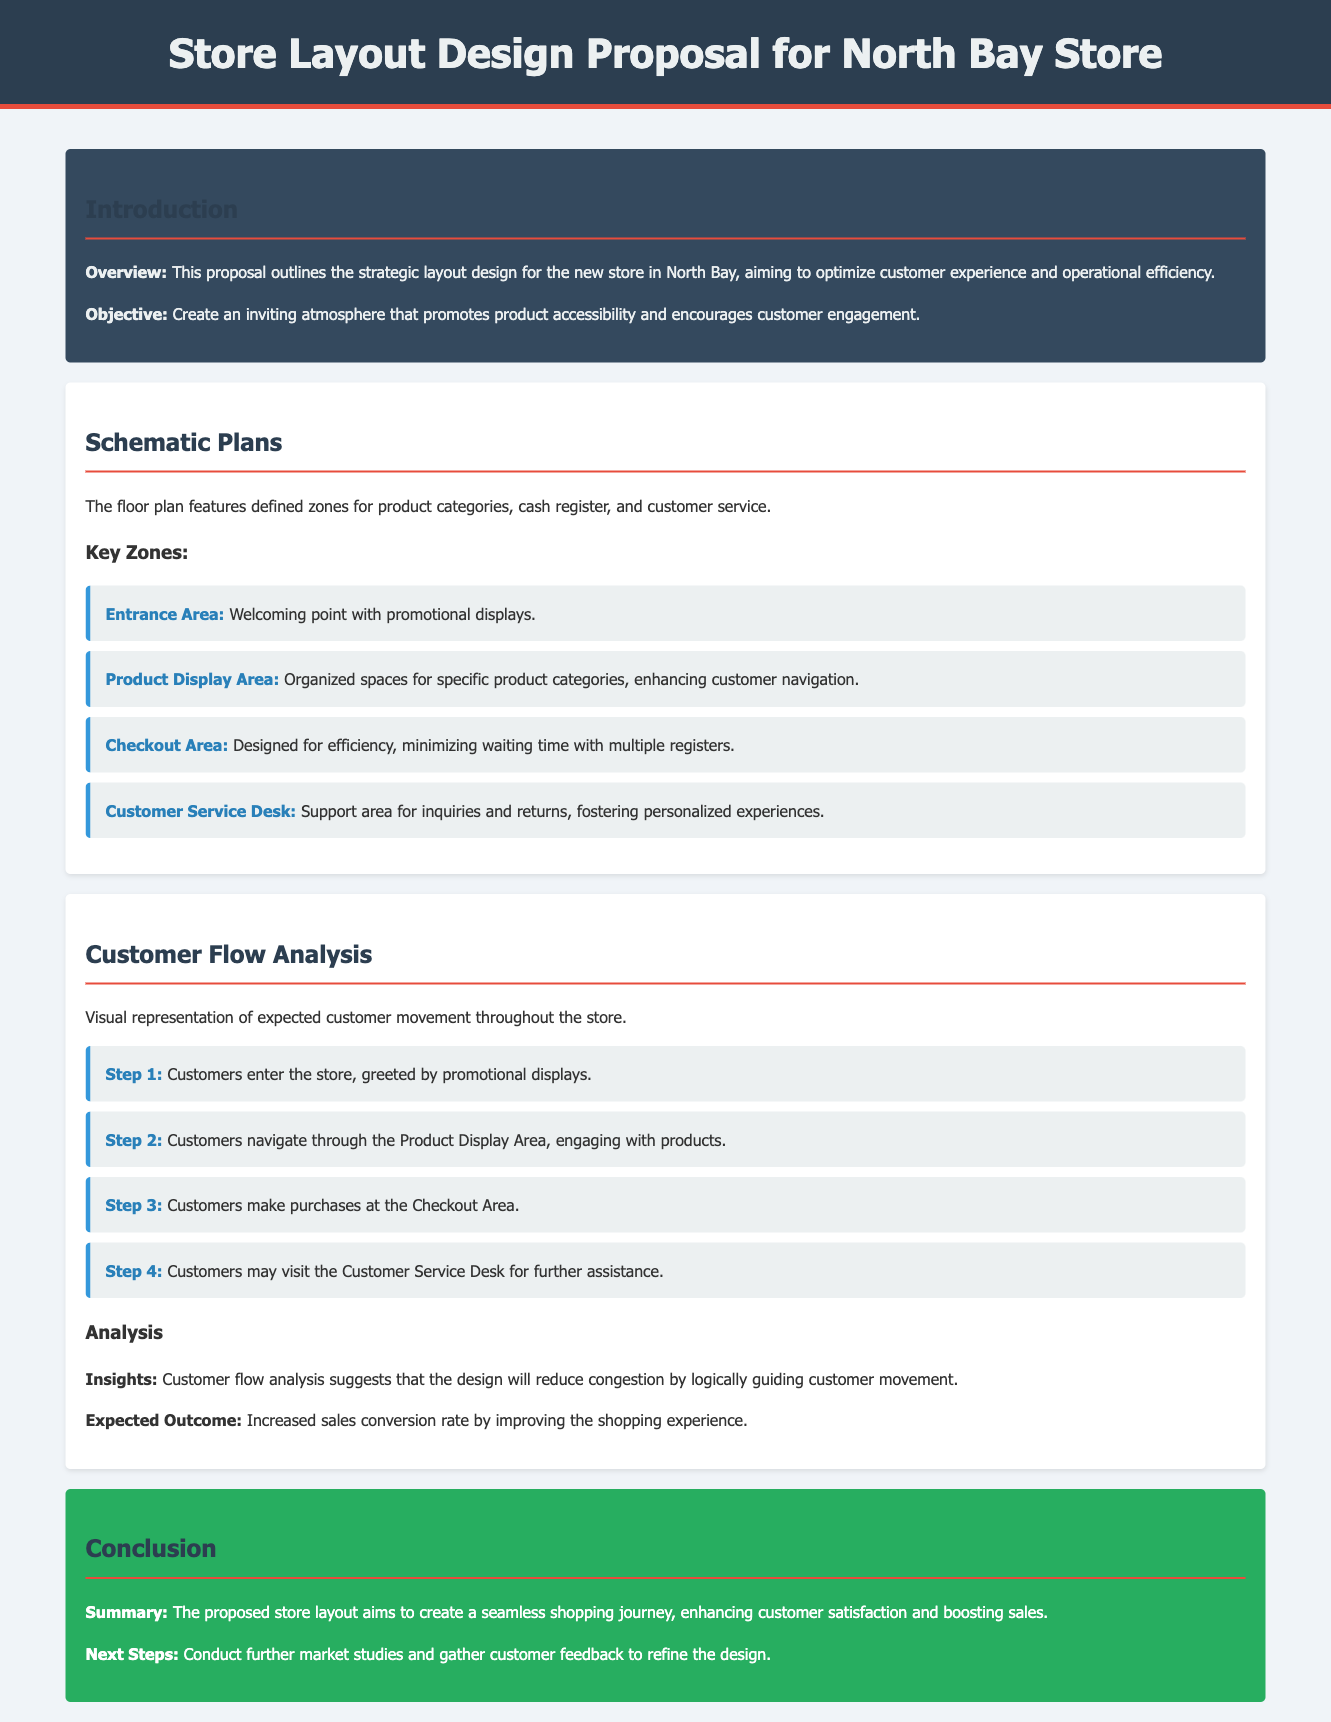What is the title of the proposal? The title is stated in the header of the document, which outlines the main subject of the content.
Answer: Store Layout Design Proposal for North Bay Store What is the objective of the store layout proposal? The objective is mentioned in the introduction section of the document, specifying the goals for the store's design.
Answer: Create an inviting atmosphere that promotes product accessibility and encourages customer engagement How many key zones are defined in the schematic plans? The number of key zones is listed as part of the schematic plans section.
Answer: Four What step involves customers entering the store? This involves the initial action in the customer flow analysis section, highlighting customer entry.
Answer: Step 1 What area is designed to minimize waiting time? The area dedicated to efficiency is specified in the schematic plans section regarding its layout.
Answer: Checkout Area What is expected to increase as a result of the proposed layout? The document mentions the outcome related to customer experience and business performance based on the design's effectiveness.
Answer: Sales conversion rate What area serves as a support for inquiries and returns? The document lists this area specifically as part of the schematic plans, describing its function.
Answer: Customer Service Desk What analysis is provided to understand customer movement? The type of assessment mentioned in the document focusing on customer patterns is indicated.
Answer: Customer Flow Analysis What should be conducted as the next steps? The next actions are pointed out in the conclusion, suggesting follow-up initiatives based on the proposal.
Answer: Conduct further market studies and gather customer feedback 